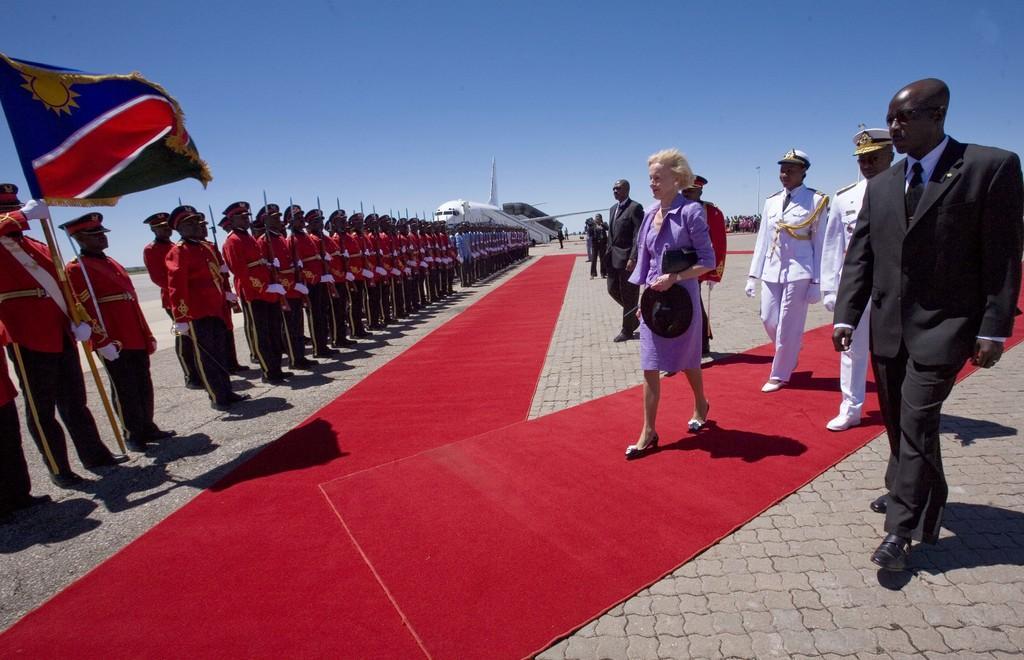In one or two sentences, can you explain what this image depicts? In the picture we can see a path on it we can see a red carpet and beside it we can see some men are standing in the uniforms and holding guns and one man is holding a pole with a flag and in front of them we can see a woman and some security people are walking and coming and in the background we can see a plane which is white in color and behind it we can see a sky. 